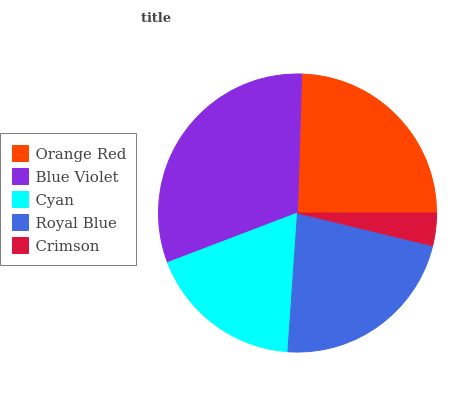Is Crimson the minimum?
Answer yes or no. Yes. Is Blue Violet the maximum?
Answer yes or no. Yes. Is Cyan the minimum?
Answer yes or no. No. Is Cyan the maximum?
Answer yes or no. No. Is Blue Violet greater than Cyan?
Answer yes or no. Yes. Is Cyan less than Blue Violet?
Answer yes or no. Yes. Is Cyan greater than Blue Violet?
Answer yes or no. No. Is Blue Violet less than Cyan?
Answer yes or no. No. Is Royal Blue the high median?
Answer yes or no. Yes. Is Royal Blue the low median?
Answer yes or no. Yes. Is Blue Violet the high median?
Answer yes or no. No. Is Crimson the low median?
Answer yes or no. No. 